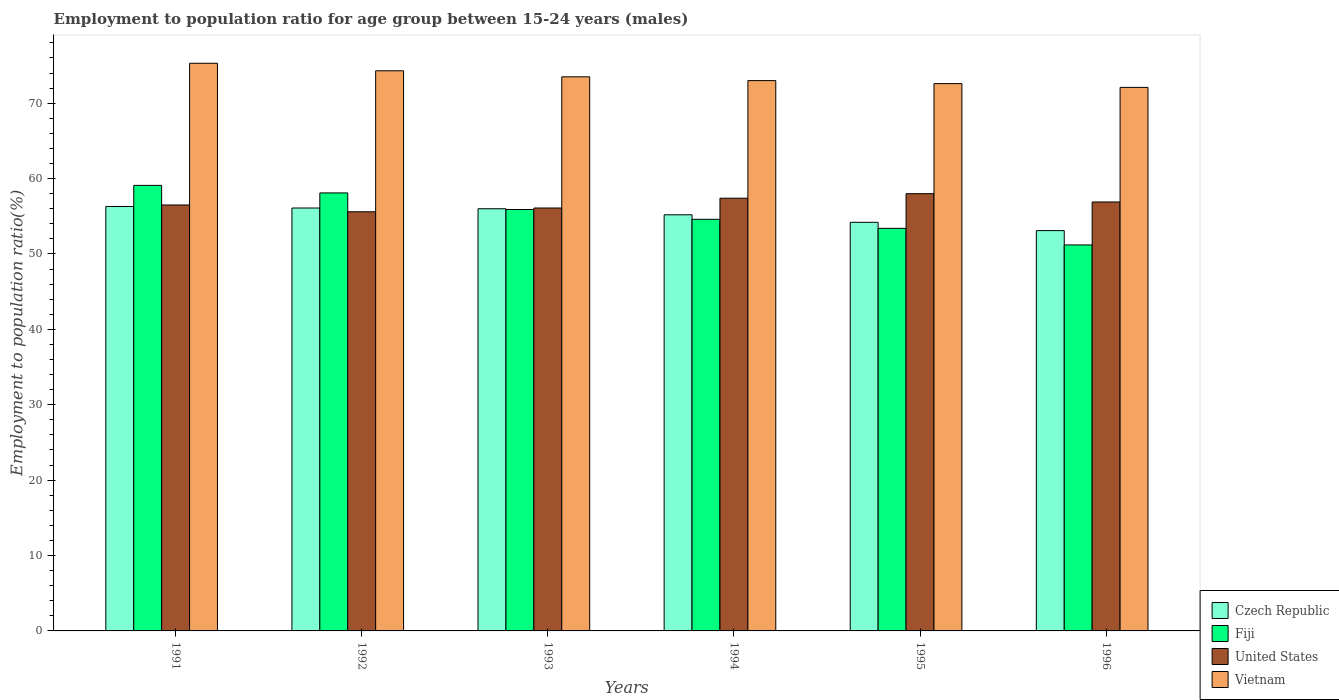Are the number of bars on each tick of the X-axis equal?
Your answer should be compact. Yes. How many bars are there on the 3rd tick from the left?
Provide a short and direct response. 4. What is the label of the 6th group of bars from the left?
Your answer should be compact. 1996. In how many cases, is the number of bars for a given year not equal to the number of legend labels?
Make the answer very short. 0. What is the employment to population ratio in United States in 1996?
Keep it short and to the point. 56.9. Across all years, what is the maximum employment to population ratio in Vietnam?
Your answer should be compact. 75.3. Across all years, what is the minimum employment to population ratio in United States?
Ensure brevity in your answer.  55.6. In which year was the employment to population ratio in Vietnam maximum?
Your response must be concise. 1991. In which year was the employment to population ratio in Fiji minimum?
Make the answer very short. 1996. What is the total employment to population ratio in Fiji in the graph?
Provide a succinct answer. 332.3. What is the difference between the employment to population ratio in Fiji in 1992 and the employment to population ratio in Vietnam in 1994?
Make the answer very short. -14.9. What is the average employment to population ratio in United States per year?
Your answer should be very brief. 56.75. In the year 1993, what is the difference between the employment to population ratio in Vietnam and employment to population ratio in United States?
Offer a very short reply. 17.4. In how many years, is the employment to population ratio in United States greater than 50 %?
Provide a succinct answer. 6. What is the ratio of the employment to population ratio in Fiji in 1992 to that in 1994?
Provide a short and direct response. 1.06. Is the difference between the employment to population ratio in Vietnam in 1991 and 1996 greater than the difference between the employment to population ratio in United States in 1991 and 1996?
Give a very brief answer. Yes. What is the difference between the highest and the second highest employment to population ratio in Czech Republic?
Provide a short and direct response. 0.2. What is the difference between the highest and the lowest employment to population ratio in Czech Republic?
Keep it short and to the point. 3.2. In how many years, is the employment to population ratio in Fiji greater than the average employment to population ratio in Fiji taken over all years?
Provide a short and direct response. 3. What does the 1st bar from the left in 1991 represents?
Offer a very short reply. Czech Republic. What does the 3rd bar from the right in 1996 represents?
Your answer should be compact. Fiji. Are all the bars in the graph horizontal?
Your response must be concise. No. How many years are there in the graph?
Offer a very short reply. 6. Are the values on the major ticks of Y-axis written in scientific E-notation?
Keep it short and to the point. No. Does the graph contain any zero values?
Your response must be concise. No. Where does the legend appear in the graph?
Provide a succinct answer. Bottom right. How many legend labels are there?
Make the answer very short. 4. What is the title of the graph?
Give a very brief answer. Employment to population ratio for age group between 15-24 years (males). Does "Senegal" appear as one of the legend labels in the graph?
Your response must be concise. No. What is the label or title of the X-axis?
Your answer should be very brief. Years. What is the Employment to population ratio(%) of Czech Republic in 1991?
Your answer should be very brief. 56.3. What is the Employment to population ratio(%) in Fiji in 1991?
Provide a short and direct response. 59.1. What is the Employment to population ratio(%) in United States in 1991?
Provide a succinct answer. 56.5. What is the Employment to population ratio(%) of Vietnam in 1991?
Provide a short and direct response. 75.3. What is the Employment to population ratio(%) in Czech Republic in 1992?
Your response must be concise. 56.1. What is the Employment to population ratio(%) in Fiji in 1992?
Provide a succinct answer. 58.1. What is the Employment to population ratio(%) in United States in 1992?
Offer a terse response. 55.6. What is the Employment to population ratio(%) of Vietnam in 1992?
Ensure brevity in your answer.  74.3. What is the Employment to population ratio(%) of Czech Republic in 1993?
Your answer should be very brief. 56. What is the Employment to population ratio(%) in Fiji in 1993?
Offer a terse response. 55.9. What is the Employment to population ratio(%) in United States in 1993?
Give a very brief answer. 56.1. What is the Employment to population ratio(%) of Vietnam in 1993?
Your response must be concise. 73.5. What is the Employment to population ratio(%) of Czech Republic in 1994?
Your answer should be very brief. 55.2. What is the Employment to population ratio(%) of Fiji in 1994?
Provide a short and direct response. 54.6. What is the Employment to population ratio(%) of United States in 1994?
Your answer should be compact. 57.4. What is the Employment to population ratio(%) of Vietnam in 1994?
Provide a short and direct response. 73. What is the Employment to population ratio(%) in Czech Republic in 1995?
Provide a short and direct response. 54.2. What is the Employment to population ratio(%) of Fiji in 1995?
Ensure brevity in your answer.  53.4. What is the Employment to population ratio(%) in Vietnam in 1995?
Keep it short and to the point. 72.6. What is the Employment to population ratio(%) in Czech Republic in 1996?
Keep it short and to the point. 53.1. What is the Employment to population ratio(%) of Fiji in 1996?
Give a very brief answer. 51.2. What is the Employment to population ratio(%) in United States in 1996?
Offer a very short reply. 56.9. What is the Employment to population ratio(%) of Vietnam in 1996?
Provide a short and direct response. 72.1. Across all years, what is the maximum Employment to population ratio(%) of Czech Republic?
Provide a succinct answer. 56.3. Across all years, what is the maximum Employment to population ratio(%) in Fiji?
Your answer should be compact. 59.1. Across all years, what is the maximum Employment to population ratio(%) of United States?
Offer a very short reply. 58. Across all years, what is the maximum Employment to population ratio(%) in Vietnam?
Make the answer very short. 75.3. Across all years, what is the minimum Employment to population ratio(%) in Czech Republic?
Ensure brevity in your answer.  53.1. Across all years, what is the minimum Employment to population ratio(%) of Fiji?
Give a very brief answer. 51.2. Across all years, what is the minimum Employment to population ratio(%) of United States?
Your response must be concise. 55.6. Across all years, what is the minimum Employment to population ratio(%) in Vietnam?
Offer a terse response. 72.1. What is the total Employment to population ratio(%) of Czech Republic in the graph?
Make the answer very short. 330.9. What is the total Employment to population ratio(%) in Fiji in the graph?
Make the answer very short. 332.3. What is the total Employment to population ratio(%) in United States in the graph?
Your answer should be compact. 340.5. What is the total Employment to population ratio(%) in Vietnam in the graph?
Make the answer very short. 440.8. What is the difference between the Employment to population ratio(%) in United States in 1991 and that in 1992?
Your answer should be compact. 0.9. What is the difference between the Employment to population ratio(%) in Fiji in 1991 and that in 1993?
Your answer should be compact. 3.2. What is the difference between the Employment to population ratio(%) of Czech Republic in 1991 and that in 1994?
Make the answer very short. 1.1. What is the difference between the Employment to population ratio(%) of Czech Republic in 1991 and that in 1996?
Offer a terse response. 3.2. What is the difference between the Employment to population ratio(%) of Fiji in 1991 and that in 1996?
Keep it short and to the point. 7.9. What is the difference between the Employment to population ratio(%) of United States in 1991 and that in 1996?
Give a very brief answer. -0.4. What is the difference between the Employment to population ratio(%) in Vietnam in 1991 and that in 1996?
Ensure brevity in your answer.  3.2. What is the difference between the Employment to population ratio(%) in Czech Republic in 1992 and that in 1993?
Make the answer very short. 0.1. What is the difference between the Employment to population ratio(%) in Fiji in 1992 and that in 1993?
Give a very brief answer. 2.2. What is the difference between the Employment to population ratio(%) of United States in 1992 and that in 1993?
Your answer should be very brief. -0.5. What is the difference between the Employment to population ratio(%) in Fiji in 1992 and that in 1994?
Offer a terse response. 3.5. What is the difference between the Employment to population ratio(%) of Vietnam in 1992 and that in 1996?
Make the answer very short. 2.2. What is the difference between the Employment to population ratio(%) of Czech Republic in 1993 and that in 1994?
Give a very brief answer. 0.8. What is the difference between the Employment to population ratio(%) in Fiji in 1993 and that in 1994?
Your response must be concise. 1.3. What is the difference between the Employment to population ratio(%) of United States in 1993 and that in 1994?
Offer a very short reply. -1.3. What is the difference between the Employment to population ratio(%) in Vietnam in 1993 and that in 1994?
Your response must be concise. 0.5. What is the difference between the Employment to population ratio(%) in Fiji in 1993 and that in 1995?
Provide a succinct answer. 2.5. What is the difference between the Employment to population ratio(%) in Vietnam in 1993 and that in 1995?
Offer a terse response. 0.9. What is the difference between the Employment to population ratio(%) of United States in 1993 and that in 1996?
Your answer should be compact. -0.8. What is the difference between the Employment to population ratio(%) of Czech Republic in 1994 and that in 1995?
Offer a terse response. 1. What is the difference between the Employment to population ratio(%) in United States in 1994 and that in 1995?
Your answer should be very brief. -0.6. What is the difference between the Employment to population ratio(%) in Fiji in 1994 and that in 1996?
Provide a short and direct response. 3.4. What is the difference between the Employment to population ratio(%) in United States in 1994 and that in 1996?
Provide a short and direct response. 0.5. What is the difference between the Employment to population ratio(%) in Czech Republic in 1995 and that in 1996?
Provide a succinct answer. 1.1. What is the difference between the Employment to population ratio(%) in Vietnam in 1995 and that in 1996?
Your response must be concise. 0.5. What is the difference between the Employment to population ratio(%) of Czech Republic in 1991 and the Employment to population ratio(%) of Fiji in 1992?
Give a very brief answer. -1.8. What is the difference between the Employment to population ratio(%) of Fiji in 1991 and the Employment to population ratio(%) of Vietnam in 1992?
Your answer should be very brief. -15.2. What is the difference between the Employment to population ratio(%) in United States in 1991 and the Employment to population ratio(%) in Vietnam in 1992?
Provide a short and direct response. -17.8. What is the difference between the Employment to population ratio(%) in Czech Republic in 1991 and the Employment to population ratio(%) in Fiji in 1993?
Offer a very short reply. 0.4. What is the difference between the Employment to population ratio(%) of Czech Republic in 1991 and the Employment to population ratio(%) of United States in 1993?
Your response must be concise. 0.2. What is the difference between the Employment to population ratio(%) of Czech Republic in 1991 and the Employment to population ratio(%) of Vietnam in 1993?
Ensure brevity in your answer.  -17.2. What is the difference between the Employment to population ratio(%) in Fiji in 1991 and the Employment to population ratio(%) in United States in 1993?
Your answer should be very brief. 3. What is the difference between the Employment to population ratio(%) in Fiji in 1991 and the Employment to population ratio(%) in Vietnam in 1993?
Ensure brevity in your answer.  -14.4. What is the difference between the Employment to population ratio(%) in United States in 1991 and the Employment to population ratio(%) in Vietnam in 1993?
Provide a short and direct response. -17. What is the difference between the Employment to population ratio(%) of Czech Republic in 1991 and the Employment to population ratio(%) of United States in 1994?
Give a very brief answer. -1.1. What is the difference between the Employment to population ratio(%) of Czech Republic in 1991 and the Employment to population ratio(%) of Vietnam in 1994?
Your response must be concise. -16.7. What is the difference between the Employment to population ratio(%) in United States in 1991 and the Employment to population ratio(%) in Vietnam in 1994?
Provide a short and direct response. -16.5. What is the difference between the Employment to population ratio(%) of Czech Republic in 1991 and the Employment to population ratio(%) of Fiji in 1995?
Keep it short and to the point. 2.9. What is the difference between the Employment to population ratio(%) in Czech Republic in 1991 and the Employment to population ratio(%) in United States in 1995?
Keep it short and to the point. -1.7. What is the difference between the Employment to population ratio(%) in Czech Republic in 1991 and the Employment to population ratio(%) in Vietnam in 1995?
Keep it short and to the point. -16.3. What is the difference between the Employment to population ratio(%) of Fiji in 1991 and the Employment to population ratio(%) of United States in 1995?
Give a very brief answer. 1.1. What is the difference between the Employment to population ratio(%) in Fiji in 1991 and the Employment to population ratio(%) in Vietnam in 1995?
Make the answer very short. -13.5. What is the difference between the Employment to population ratio(%) of United States in 1991 and the Employment to population ratio(%) of Vietnam in 1995?
Your answer should be compact. -16.1. What is the difference between the Employment to population ratio(%) in Czech Republic in 1991 and the Employment to population ratio(%) in United States in 1996?
Provide a succinct answer. -0.6. What is the difference between the Employment to population ratio(%) of Czech Republic in 1991 and the Employment to population ratio(%) of Vietnam in 1996?
Your response must be concise. -15.8. What is the difference between the Employment to population ratio(%) in Fiji in 1991 and the Employment to population ratio(%) in United States in 1996?
Your answer should be very brief. 2.2. What is the difference between the Employment to population ratio(%) in United States in 1991 and the Employment to population ratio(%) in Vietnam in 1996?
Your response must be concise. -15.6. What is the difference between the Employment to population ratio(%) of Czech Republic in 1992 and the Employment to population ratio(%) of United States in 1993?
Your response must be concise. 0. What is the difference between the Employment to population ratio(%) in Czech Republic in 1992 and the Employment to population ratio(%) in Vietnam in 1993?
Give a very brief answer. -17.4. What is the difference between the Employment to population ratio(%) in Fiji in 1992 and the Employment to population ratio(%) in United States in 1993?
Your answer should be compact. 2. What is the difference between the Employment to population ratio(%) of Fiji in 1992 and the Employment to population ratio(%) of Vietnam in 1993?
Ensure brevity in your answer.  -15.4. What is the difference between the Employment to population ratio(%) of United States in 1992 and the Employment to population ratio(%) of Vietnam in 1993?
Make the answer very short. -17.9. What is the difference between the Employment to population ratio(%) in Czech Republic in 1992 and the Employment to population ratio(%) in Fiji in 1994?
Offer a terse response. 1.5. What is the difference between the Employment to population ratio(%) in Czech Republic in 1992 and the Employment to population ratio(%) in Vietnam in 1994?
Offer a very short reply. -16.9. What is the difference between the Employment to population ratio(%) in Fiji in 1992 and the Employment to population ratio(%) in United States in 1994?
Offer a very short reply. 0.7. What is the difference between the Employment to population ratio(%) in Fiji in 1992 and the Employment to population ratio(%) in Vietnam in 1994?
Give a very brief answer. -14.9. What is the difference between the Employment to population ratio(%) in United States in 1992 and the Employment to population ratio(%) in Vietnam in 1994?
Offer a terse response. -17.4. What is the difference between the Employment to population ratio(%) in Czech Republic in 1992 and the Employment to population ratio(%) in United States in 1995?
Provide a short and direct response. -1.9. What is the difference between the Employment to population ratio(%) in Czech Republic in 1992 and the Employment to population ratio(%) in Vietnam in 1995?
Provide a short and direct response. -16.5. What is the difference between the Employment to population ratio(%) in Fiji in 1992 and the Employment to population ratio(%) in Vietnam in 1995?
Give a very brief answer. -14.5. What is the difference between the Employment to population ratio(%) of United States in 1992 and the Employment to population ratio(%) of Vietnam in 1995?
Your answer should be very brief. -17. What is the difference between the Employment to population ratio(%) of Czech Republic in 1992 and the Employment to population ratio(%) of United States in 1996?
Provide a short and direct response. -0.8. What is the difference between the Employment to population ratio(%) in Czech Republic in 1992 and the Employment to population ratio(%) in Vietnam in 1996?
Offer a very short reply. -16. What is the difference between the Employment to population ratio(%) of United States in 1992 and the Employment to population ratio(%) of Vietnam in 1996?
Ensure brevity in your answer.  -16.5. What is the difference between the Employment to population ratio(%) in Czech Republic in 1993 and the Employment to population ratio(%) in Vietnam in 1994?
Keep it short and to the point. -17. What is the difference between the Employment to population ratio(%) of Fiji in 1993 and the Employment to population ratio(%) of United States in 1994?
Your answer should be compact. -1.5. What is the difference between the Employment to population ratio(%) of Fiji in 1993 and the Employment to population ratio(%) of Vietnam in 1994?
Your answer should be very brief. -17.1. What is the difference between the Employment to population ratio(%) in United States in 1993 and the Employment to population ratio(%) in Vietnam in 1994?
Make the answer very short. -16.9. What is the difference between the Employment to population ratio(%) of Czech Republic in 1993 and the Employment to population ratio(%) of Fiji in 1995?
Give a very brief answer. 2.6. What is the difference between the Employment to population ratio(%) of Czech Republic in 1993 and the Employment to population ratio(%) of United States in 1995?
Give a very brief answer. -2. What is the difference between the Employment to population ratio(%) in Czech Republic in 1993 and the Employment to population ratio(%) in Vietnam in 1995?
Offer a very short reply. -16.6. What is the difference between the Employment to population ratio(%) of Fiji in 1993 and the Employment to population ratio(%) of Vietnam in 1995?
Your answer should be compact. -16.7. What is the difference between the Employment to population ratio(%) of United States in 1993 and the Employment to population ratio(%) of Vietnam in 1995?
Offer a very short reply. -16.5. What is the difference between the Employment to population ratio(%) in Czech Republic in 1993 and the Employment to population ratio(%) in Fiji in 1996?
Make the answer very short. 4.8. What is the difference between the Employment to population ratio(%) in Czech Republic in 1993 and the Employment to population ratio(%) in Vietnam in 1996?
Your answer should be compact. -16.1. What is the difference between the Employment to population ratio(%) of Fiji in 1993 and the Employment to population ratio(%) of United States in 1996?
Keep it short and to the point. -1. What is the difference between the Employment to population ratio(%) in Fiji in 1993 and the Employment to population ratio(%) in Vietnam in 1996?
Your response must be concise. -16.2. What is the difference between the Employment to population ratio(%) of United States in 1993 and the Employment to population ratio(%) of Vietnam in 1996?
Your answer should be very brief. -16. What is the difference between the Employment to population ratio(%) of Czech Republic in 1994 and the Employment to population ratio(%) of Fiji in 1995?
Make the answer very short. 1.8. What is the difference between the Employment to population ratio(%) in Czech Republic in 1994 and the Employment to population ratio(%) in Vietnam in 1995?
Provide a short and direct response. -17.4. What is the difference between the Employment to population ratio(%) in Fiji in 1994 and the Employment to population ratio(%) in United States in 1995?
Make the answer very short. -3.4. What is the difference between the Employment to population ratio(%) in United States in 1994 and the Employment to population ratio(%) in Vietnam in 1995?
Your answer should be very brief. -15.2. What is the difference between the Employment to population ratio(%) in Czech Republic in 1994 and the Employment to population ratio(%) in United States in 1996?
Keep it short and to the point. -1.7. What is the difference between the Employment to population ratio(%) in Czech Republic in 1994 and the Employment to population ratio(%) in Vietnam in 1996?
Offer a very short reply. -16.9. What is the difference between the Employment to population ratio(%) in Fiji in 1994 and the Employment to population ratio(%) in Vietnam in 1996?
Keep it short and to the point. -17.5. What is the difference between the Employment to population ratio(%) in United States in 1994 and the Employment to population ratio(%) in Vietnam in 1996?
Offer a very short reply. -14.7. What is the difference between the Employment to population ratio(%) in Czech Republic in 1995 and the Employment to population ratio(%) in United States in 1996?
Keep it short and to the point. -2.7. What is the difference between the Employment to population ratio(%) of Czech Republic in 1995 and the Employment to population ratio(%) of Vietnam in 1996?
Offer a very short reply. -17.9. What is the difference between the Employment to population ratio(%) in Fiji in 1995 and the Employment to population ratio(%) in Vietnam in 1996?
Give a very brief answer. -18.7. What is the difference between the Employment to population ratio(%) of United States in 1995 and the Employment to population ratio(%) of Vietnam in 1996?
Make the answer very short. -14.1. What is the average Employment to population ratio(%) in Czech Republic per year?
Your answer should be very brief. 55.15. What is the average Employment to population ratio(%) in Fiji per year?
Your response must be concise. 55.38. What is the average Employment to population ratio(%) of United States per year?
Provide a succinct answer. 56.75. What is the average Employment to population ratio(%) of Vietnam per year?
Keep it short and to the point. 73.47. In the year 1991, what is the difference between the Employment to population ratio(%) of Czech Republic and Employment to population ratio(%) of Fiji?
Offer a very short reply. -2.8. In the year 1991, what is the difference between the Employment to population ratio(%) of Czech Republic and Employment to population ratio(%) of United States?
Ensure brevity in your answer.  -0.2. In the year 1991, what is the difference between the Employment to population ratio(%) of Czech Republic and Employment to population ratio(%) of Vietnam?
Offer a very short reply. -19. In the year 1991, what is the difference between the Employment to population ratio(%) in Fiji and Employment to population ratio(%) in Vietnam?
Keep it short and to the point. -16.2. In the year 1991, what is the difference between the Employment to population ratio(%) of United States and Employment to population ratio(%) of Vietnam?
Give a very brief answer. -18.8. In the year 1992, what is the difference between the Employment to population ratio(%) of Czech Republic and Employment to population ratio(%) of Vietnam?
Keep it short and to the point. -18.2. In the year 1992, what is the difference between the Employment to population ratio(%) in Fiji and Employment to population ratio(%) in United States?
Your response must be concise. 2.5. In the year 1992, what is the difference between the Employment to population ratio(%) in Fiji and Employment to population ratio(%) in Vietnam?
Provide a short and direct response. -16.2. In the year 1992, what is the difference between the Employment to population ratio(%) of United States and Employment to population ratio(%) of Vietnam?
Your answer should be very brief. -18.7. In the year 1993, what is the difference between the Employment to population ratio(%) in Czech Republic and Employment to population ratio(%) in United States?
Provide a succinct answer. -0.1. In the year 1993, what is the difference between the Employment to population ratio(%) of Czech Republic and Employment to population ratio(%) of Vietnam?
Make the answer very short. -17.5. In the year 1993, what is the difference between the Employment to population ratio(%) in Fiji and Employment to population ratio(%) in United States?
Give a very brief answer. -0.2. In the year 1993, what is the difference between the Employment to population ratio(%) in Fiji and Employment to population ratio(%) in Vietnam?
Your response must be concise. -17.6. In the year 1993, what is the difference between the Employment to population ratio(%) in United States and Employment to population ratio(%) in Vietnam?
Offer a terse response. -17.4. In the year 1994, what is the difference between the Employment to population ratio(%) of Czech Republic and Employment to population ratio(%) of Fiji?
Offer a terse response. 0.6. In the year 1994, what is the difference between the Employment to population ratio(%) of Czech Republic and Employment to population ratio(%) of Vietnam?
Provide a succinct answer. -17.8. In the year 1994, what is the difference between the Employment to population ratio(%) in Fiji and Employment to population ratio(%) in United States?
Provide a succinct answer. -2.8. In the year 1994, what is the difference between the Employment to population ratio(%) of Fiji and Employment to population ratio(%) of Vietnam?
Provide a short and direct response. -18.4. In the year 1994, what is the difference between the Employment to population ratio(%) in United States and Employment to population ratio(%) in Vietnam?
Make the answer very short. -15.6. In the year 1995, what is the difference between the Employment to population ratio(%) in Czech Republic and Employment to population ratio(%) in Vietnam?
Ensure brevity in your answer.  -18.4. In the year 1995, what is the difference between the Employment to population ratio(%) in Fiji and Employment to population ratio(%) in United States?
Make the answer very short. -4.6. In the year 1995, what is the difference between the Employment to population ratio(%) of Fiji and Employment to population ratio(%) of Vietnam?
Offer a terse response. -19.2. In the year 1995, what is the difference between the Employment to population ratio(%) in United States and Employment to population ratio(%) in Vietnam?
Make the answer very short. -14.6. In the year 1996, what is the difference between the Employment to population ratio(%) of Fiji and Employment to population ratio(%) of Vietnam?
Your answer should be very brief. -20.9. In the year 1996, what is the difference between the Employment to population ratio(%) in United States and Employment to population ratio(%) in Vietnam?
Give a very brief answer. -15.2. What is the ratio of the Employment to population ratio(%) of Czech Republic in 1991 to that in 1992?
Your answer should be very brief. 1. What is the ratio of the Employment to population ratio(%) in Fiji in 1991 to that in 1992?
Provide a succinct answer. 1.02. What is the ratio of the Employment to population ratio(%) in United States in 1991 to that in 1992?
Provide a succinct answer. 1.02. What is the ratio of the Employment to population ratio(%) of Vietnam in 1991 to that in 1992?
Give a very brief answer. 1.01. What is the ratio of the Employment to population ratio(%) of Czech Republic in 1991 to that in 1993?
Provide a short and direct response. 1.01. What is the ratio of the Employment to population ratio(%) in Fiji in 1991 to that in 1993?
Offer a very short reply. 1.06. What is the ratio of the Employment to population ratio(%) in United States in 1991 to that in 1993?
Give a very brief answer. 1.01. What is the ratio of the Employment to population ratio(%) of Vietnam in 1991 to that in 1993?
Make the answer very short. 1.02. What is the ratio of the Employment to population ratio(%) in Czech Republic in 1991 to that in 1994?
Provide a succinct answer. 1.02. What is the ratio of the Employment to population ratio(%) in Fiji in 1991 to that in 1994?
Make the answer very short. 1.08. What is the ratio of the Employment to population ratio(%) of United States in 1991 to that in 1994?
Keep it short and to the point. 0.98. What is the ratio of the Employment to population ratio(%) in Vietnam in 1991 to that in 1994?
Offer a very short reply. 1.03. What is the ratio of the Employment to population ratio(%) in Czech Republic in 1991 to that in 1995?
Your response must be concise. 1.04. What is the ratio of the Employment to population ratio(%) in Fiji in 1991 to that in 1995?
Provide a short and direct response. 1.11. What is the ratio of the Employment to population ratio(%) of United States in 1991 to that in 1995?
Your answer should be compact. 0.97. What is the ratio of the Employment to population ratio(%) in Vietnam in 1991 to that in 1995?
Make the answer very short. 1.04. What is the ratio of the Employment to population ratio(%) in Czech Republic in 1991 to that in 1996?
Provide a short and direct response. 1.06. What is the ratio of the Employment to population ratio(%) in Fiji in 1991 to that in 1996?
Your answer should be compact. 1.15. What is the ratio of the Employment to population ratio(%) of Vietnam in 1991 to that in 1996?
Provide a short and direct response. 1.04. What is the ratio of the Employment to population ratio(%) in Fiji in 1992 to that in 1993?
Offer a terse response. 1.04. What is the ratio of the Employment to population ratio(%) of United States in 1992 to that in 1993?
Offer a terse response. 0.99. What is the ratio of the Employment to population ratio(%) of Vietnam in 1992 to that in 1993?
Provide a succinct answer. 1.01. What is the ratio of the Employment to population ratio(%) of Czech Republic in 1992 to that in 1994?
Provide a short and direct response. 1.02. What is the ratio of the Employment to population ratio(%) of Fiji in 1992 to that in 1994?
Offer a very short reply. 1.06. What is the ratio of the Employment to population ratio(%) in United States in 1992 to that in 1994?
Offer a very short reply. 0.97. What is the ratio of the Employment to population ratio(%) in Vietnam in 1992 to that in 1994?
Give a very brief answer. 1.02. What is the ratio of the Employment to population ratio(%) of Czech Republic in 1992 to that in 1995?
Offer a terse response. 1.04. What is the ratio of the Employment to population ratio(%) of Fiji in 1992 to that in 1995?
Offer a terse response. 1.09. What is the ratio of the Employment to population ratio(%) in United States in 1992 to that in 1995?
Give a very brief answer. 0.96. What is the ratio of the Employment to population ratio(%) in Vietnam in 1992 to that in 1995?
Provide a succinct answer. 1.02. What is the ratio of the Employment to population ratio(%) in Czech Republic in 1992 to that in 1996?
Provide a succinct answer. 1.06. What is the ratio of the Employment to population ratio(%) of Fiji in 1992 to that in 1996?
Your answer should be compact. 1.13. What is the ratio of the Employment to population ratio(%) of United States in 1992 to that in 1996?
Your answer should be compact. 0.98. What is the ratio of the Employment to population ratio(%) in Vietnam in 1992 to that in 1996?
Ensure brevity in your answer.  1.03. What is the ratio of the Employment to population ratio(%) in Czech Republic in 1993 to that in 1994?
Ensure brevity in your answer.  1.01. What is the ratio of the Employment to population ratio(%) in Fiji in 1993 to that in 1994?
Offer a very short reply. 1.02. What is the ratio of the Employment to population ratio(%) in United States in 1993 to that in 1994?
Keep it short and to the point. 0.98. What is the ratio of the Employment to population ratio(%) in Vietnam in 1993 to that in 1994?
Offer a very short reply. 1.01. What is the ratio of the Employment to population ratio(%) of Czech Republic in 1993 to that in 1995?
Offer a terse response. 1.03. What is the ratio of the Employment to population ratio(%) in Fiji in 1993 to that in 1995?
Offer a very short reply. 1.05. What is the ratio of the Employment to population ratio(%) of United States in 1993 to that in 1995?
Provide a succinct answer. 0.97. What is the ratio of the Employment to population ratio(%) of Vietnam in 1993 to that in 1995?
Offer a terse response. 1.01. What is the ratio of the Employment to population ratio(%) of Czech Republic in 1993 to that in 1996?
Offer a very short reply. 1.05. What is the ratio of the Employment to population ratio(%) of Fiji in 1993 to that in 1996?
Your answer should be compact. 1.09. What is the ratio of the Employment to population ratio(%) of United States in 1993 to that in 1996?
Ensure brevity in your answer.  0.99. What is the ratio of the Employment to population ratio(%) in Vietnam in 1993 to that in 1996?
Make the answer very short. 1.02. What is the ratio of the Employment to population ratio(%) in Czech Republic in 1994 to that in 1995?
Provide a short and direct response. 1.02. What is the ratio of the Employment to population ratio(%) in Fiji in 1994 to that in 1995?
Your response must be concise. 1.02. What is the ratio of the Employment to population ratio(%) in Vietnam in 1994 to that in 1995?
Provide a succinct answer. 1.01. What is the ratio of the Employment to population ratio(%) in Czech Republic in 1994 to that in 1996?
Offer a very short reply. 1.04. What is the ratio of the Employment to population ratio(%) of Fiji in 1994 to that in 1996?
Your answer should be very brief. 1.07. What is the ratio of the Employment to population ratio(%) of United States in 1994 to that in 1996?
Your response must be concise. 1.01. What is the ratio of the Employment to population ratio(%) of Vietnam in 1994 to that in 1996?
Your answer should be compact. 1.01. What is the ratio of the Employment to population ratio(%) in Czech Republic in 1995 to that in 1996?
Make the answer very short. 1.02. What is the ratio of the Employment to population ratio(%) of Fiji in 1995 to that in 1996?
Give a very brief answer. 1.04. What is the ratio of the Employment to population ratio(%) of United States in 1995 to that in 1996?
Your answer should be compact. 1.02. What is the ratio of the Employment to population ratio(%) of Vietnam in 1995 to that in 1996?
Keep it short and to the point. 1.01. What is the difference between the highest and the second highest Employment to population ratio(%) of United States?
Your answer should be very brief. 0.6. What is the difference between the highest and the second highest Employment to population ratio(%) in Vietnam?
Your answer should be compact. 1. What is the difference between the highest and the lowest Employment to population ratio(%) of Fiji?
Your answer should be very brief. 7.9. 